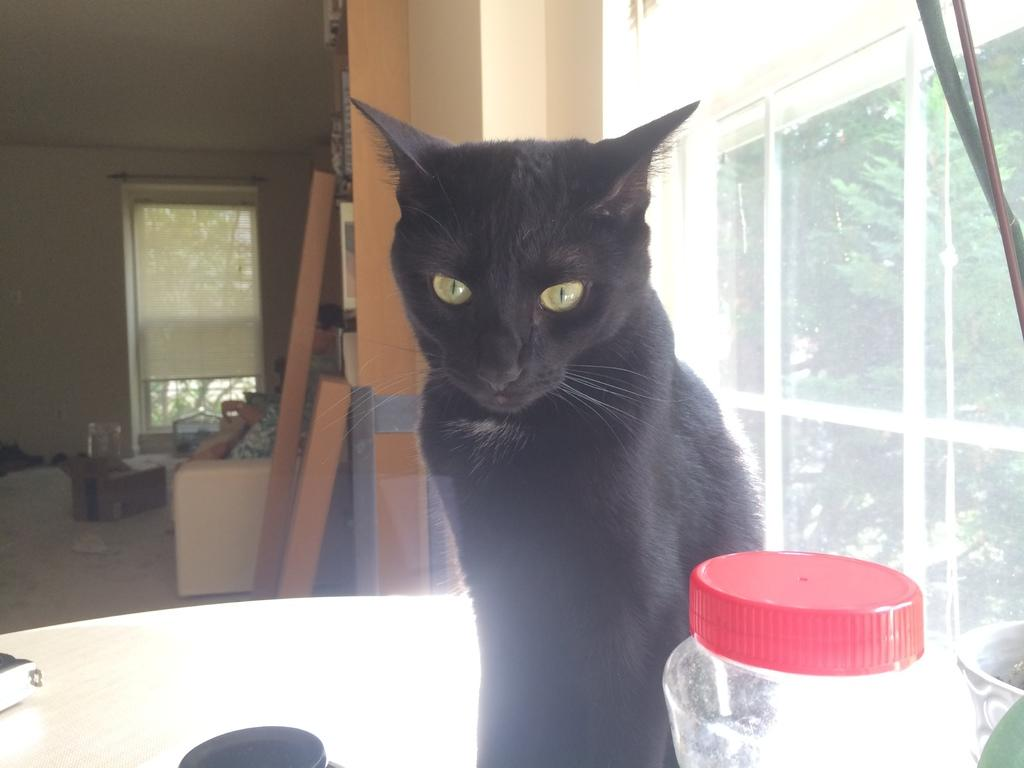What animal is on the table in the image? There is a cat on the table in the image. What objects are visible on the table with the cat? There is a bottle and a glass visible on the table with the cat. What can be seen in the background of the image? Trees, a wall, and a door are visible in the background of the image. How many roses are on the table with the cat in the image? There are no roses present in the image; it only features a cat, a bottle, and a glass on the table. 